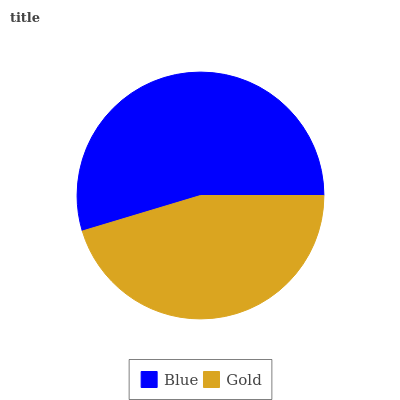Is Gold the minimum?
Answer yes or no. Yes. Is Blue the maximum?
Answer yes or no. Yes. Is Gold the maximum?
Answer yes or no. No. Is Blue greater than Gold?
Answer yes or no. Yes. Is Gold less than Blue?
Answer yes or no. Yes. Is Gold greater than Blue?
Answer yes or no. No. Is Blue less than Gold?
Answer yes or no. No. Is Blue the high median?
Answer yes or no. Yes. Is Gold the low median?
Answer yes or no. Yes. Is Gold the high median?
Answer yes or no. No. Is Blue the low median?
Answer yes or no. No. 